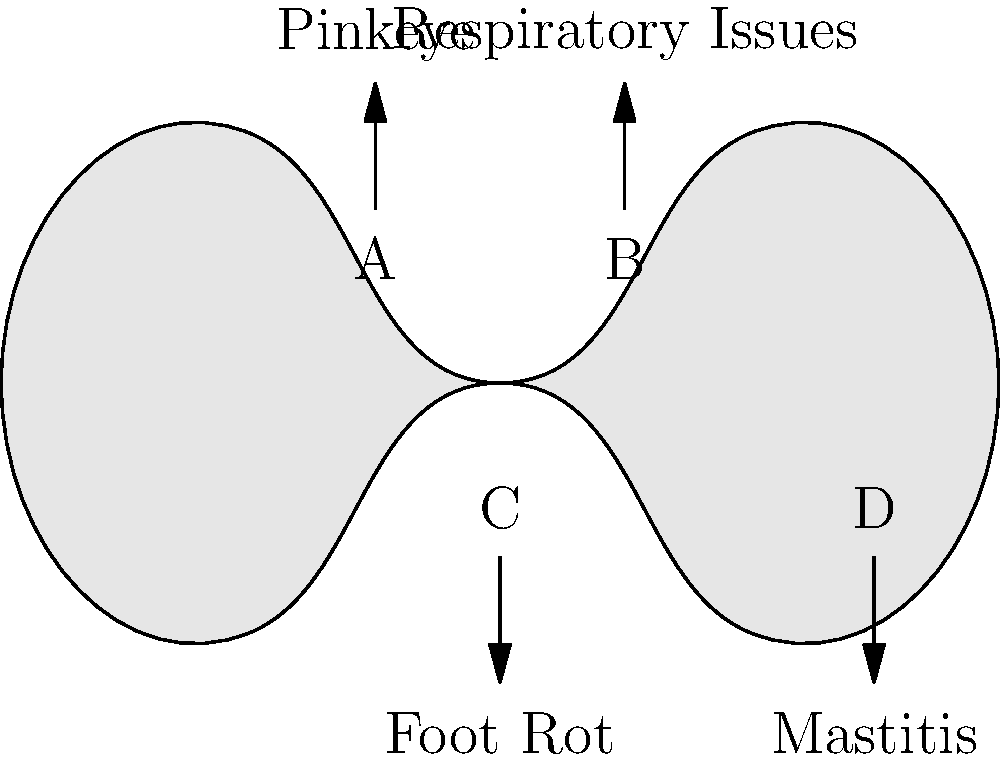Based on the labeled illustration of a cow, which area marked with the letter "D" is commonly associated with mastitis in cattle? To answer this question, let's follow these steps:

1. Observe the illustration carefully. It shows a simplified outline of a cow with four labeled areas (A, B, C, and D).

2. Each labeled area has an arrow pointing to a specific disease name.

3. Look for the area marked with the letter "D". This is located in the lower right part of the cow's body.

4. The arrow from area "D" points to the disease name "Mastitis".

5. Mastitis is an inflammation of the mammary gland and udder tissue, which affects milk-producing animals.

6. The udder, where milk is produced, is located in the rear lower part of a cow's body, which corresponds to the area labeled "D" in this illustration.

Therefore, the area marked with the letter "D" is commonly associated with mastitis in cattle.
Answer: Udder 